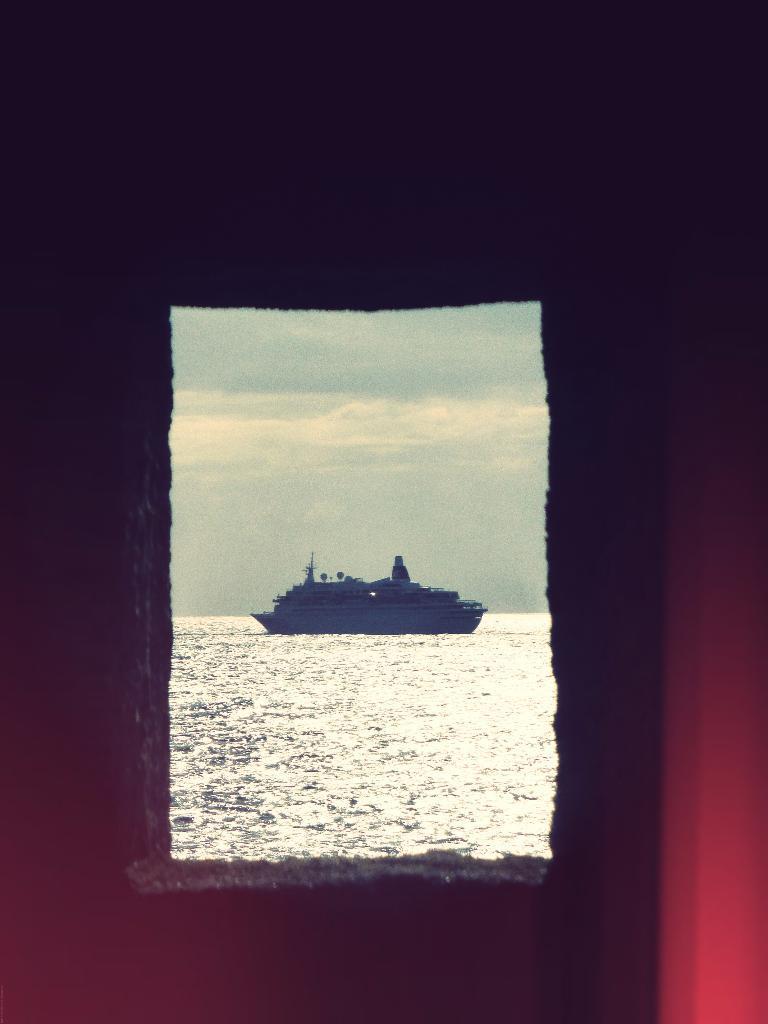Please provide a concise description of this image. In this picture we can see water, there is a ship in the water, we can see the sky in the background, here we can see a dark background. 